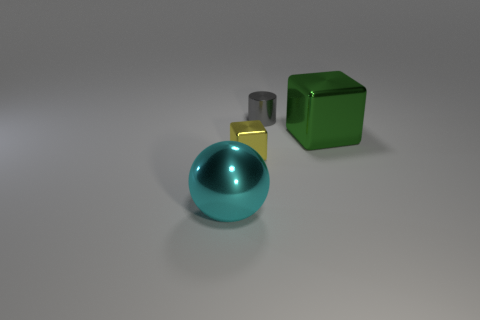How many gray metallic cylinders have the same size as the yellow object?
Provide a succinct answer. 1. Is the number of metal cubes less than the number of metal objects?
Keep it short and to the point. Yes. Are there any other things that have the same color as the large metal ball?
Offer a terse response. No. What is the shape of the cyan thing that is made of the same material as the yellow thing?
Your answer should be compact. Sphere. How many yellow metallic objects are behind the big object on the left side of the big shiny object to the right of the metal ball?
Keep it short and to the point. 1. There is a metal thing that is both in front of the green metallic thing and on the right side of the cyan metal sphere; what is its shape?
Your answer should be very brief. Cube. Is the number of cyan shiny things that are in front of the large cyan metallic ball less than the number of small yellow shiny cubes?
Your answer should be compact. Yes. What number of large things are shiny blocks or balls?
Your answer should be compact. 2. What size is the yellow object?
Offer a very short reply. Small. There is a big cyan shiny object; how many gray metallic cylinders are on the left side of it?
Your answer should be compact. 0. 